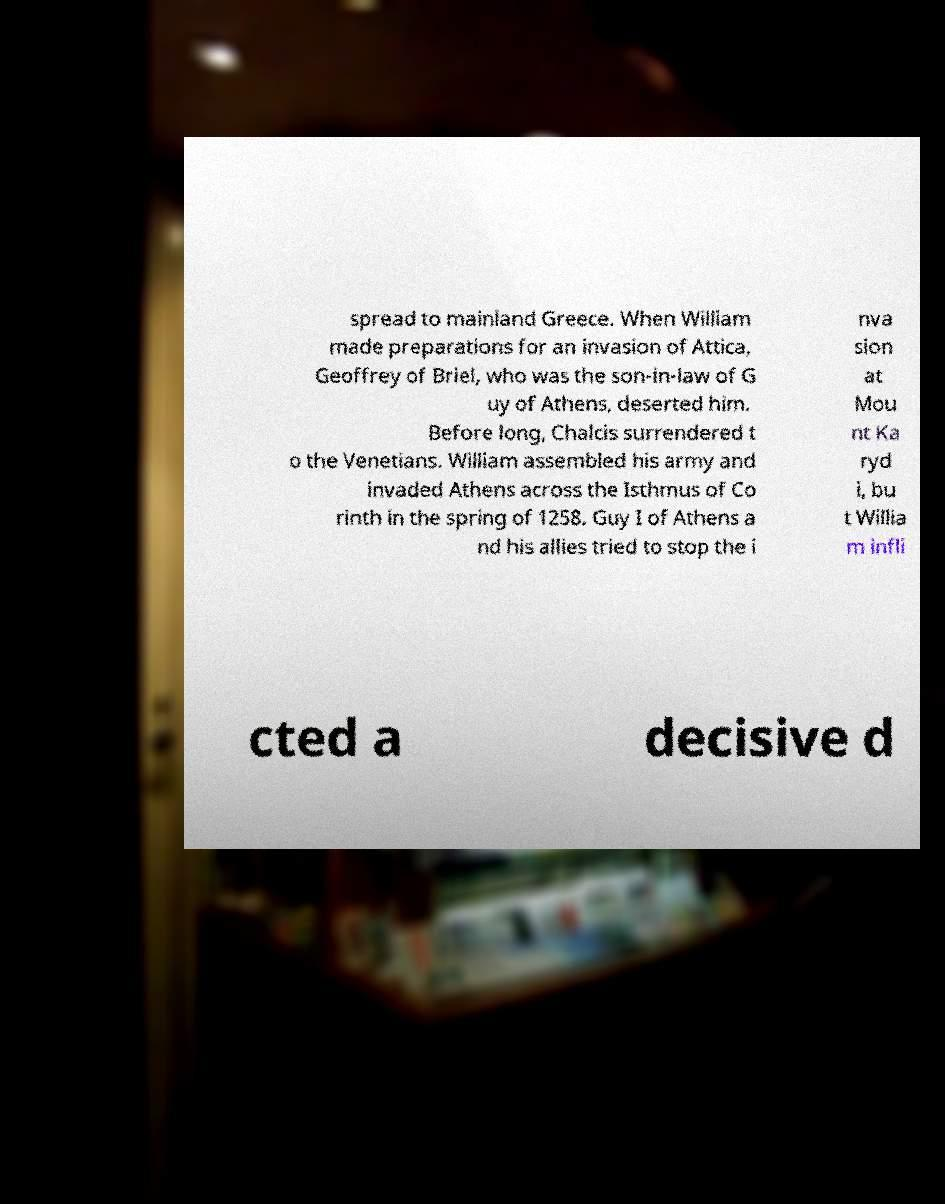Can you accurately transcribe the text from the provided image for me? spread to mainland Greece. When William made preparations for an invasion of Attica, Geoffrey of Briel, who was the son-in-law of G uy of Athens, deserted him. Before long, Chalcis surrendered t o the Venetians. William assembled his army and invaded Athens across the Isthmus of Co rinth in the spring of 1258. Guy I of Athens a nd his allies tried to stop the i nva sion at Mou nt Ka ryd i, bu t Willia m infli cted a decisive d 